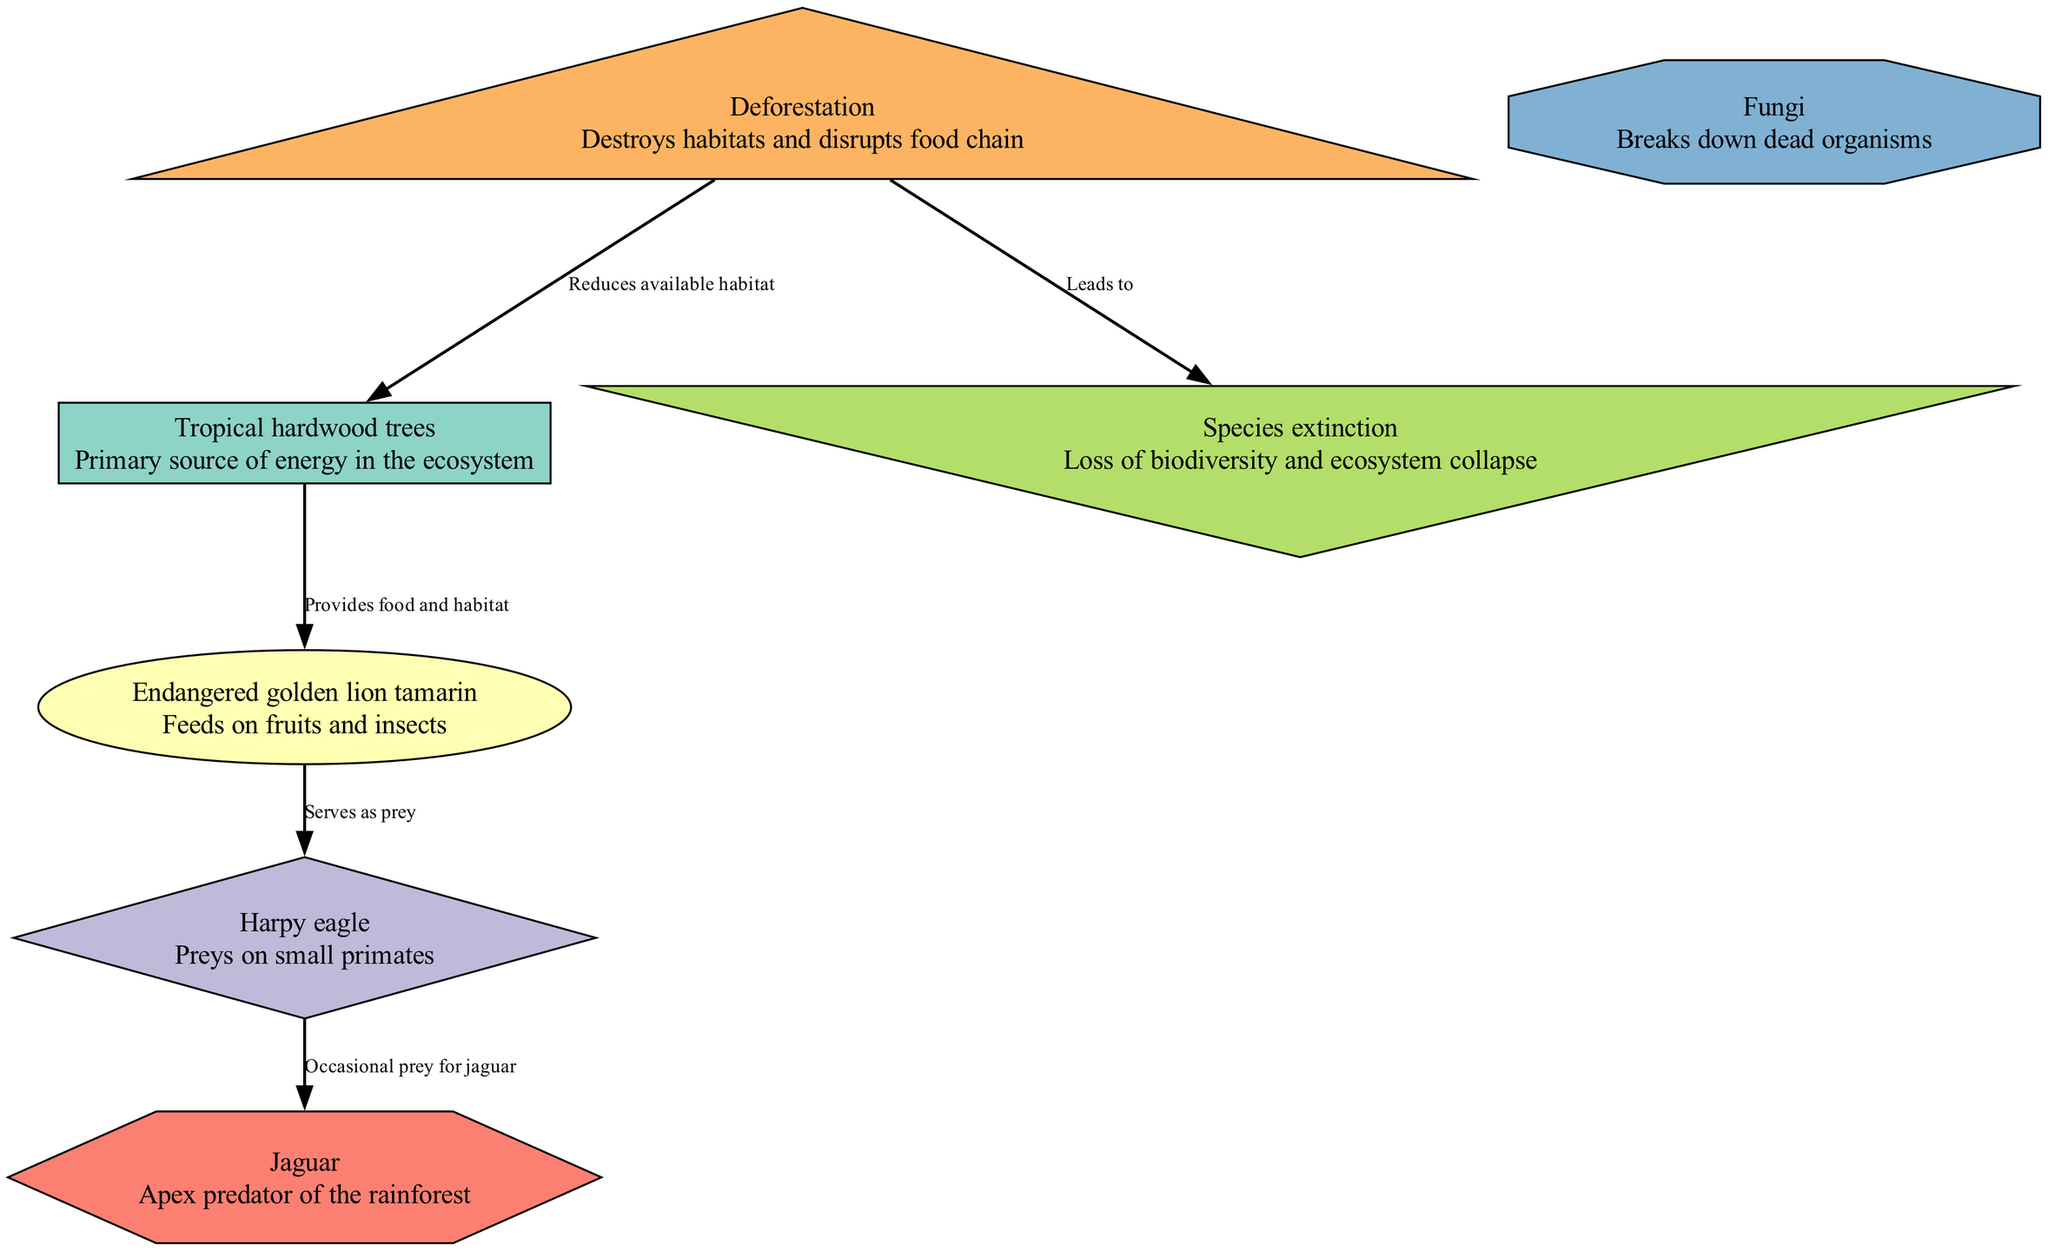What is the primary producer in the food chain? The diagram shows that the primary producer is the "Tropical hardwood trees," which is the first element in the food chain providing energy for other organisms.
Answer: Tropical hardwood trees How many consumers are listed in the diagram? By counting the nodes defined as consumers (primary, secondary, and tertiary), which include "Endangered golden lion tamarin," "Harpy eagle," and "Jaguar," a total of three consumers is identified.
Answer: 3 What does the "Endangered golden lion tamarin" feed on? The description linked to the "Endangered golden lion tamarin" node states that it feeds on fruits and insects, which indicates its place in the food chain as a primary consumer.
Answer: Fruits and insects Which animal serves as an occasional prey for the Jaguar? The edge from "Harpy eagle" to "Jaguar" shows that the "Harpy eagle" is the occasional prey for the Jaguar, clarifying the predator-prey relationship in the food chain.
Answer: Harpy eagle What impact does deforestation have on tropical hardwood trees? The relationship line from "Deforestation" to "Tropical hardwood trees" indicates that deforestation reduces the available habitat for these trees, impacting their survival and the entire ecosystem.
Answer: Reduces available habitat What is a consequence of deforestation mentioned in the diagram? The diagram clearly shows the consequence of deforestation leading to "Species extinction," indicating the broader ecological impact of habitat loss.
Answer: Species extinction How does the food chain illustrate the relationship between the Endangered golden lion tamarin and Harpy eagle? The diagram illustrates that the "Endangered golden lion tamarin" serves as prey for the "Harpy eagle," indicating a direct predator-prey interaction in the food chain.
Answer: Serves as prey What role do Fungi play in the food chain? According to the diagram, "Fungi" are categorized as decomposers, which play a vital role in breaking down dead organisms and recycling nutrients back into the ecosystem.
Answer: Decomposer 